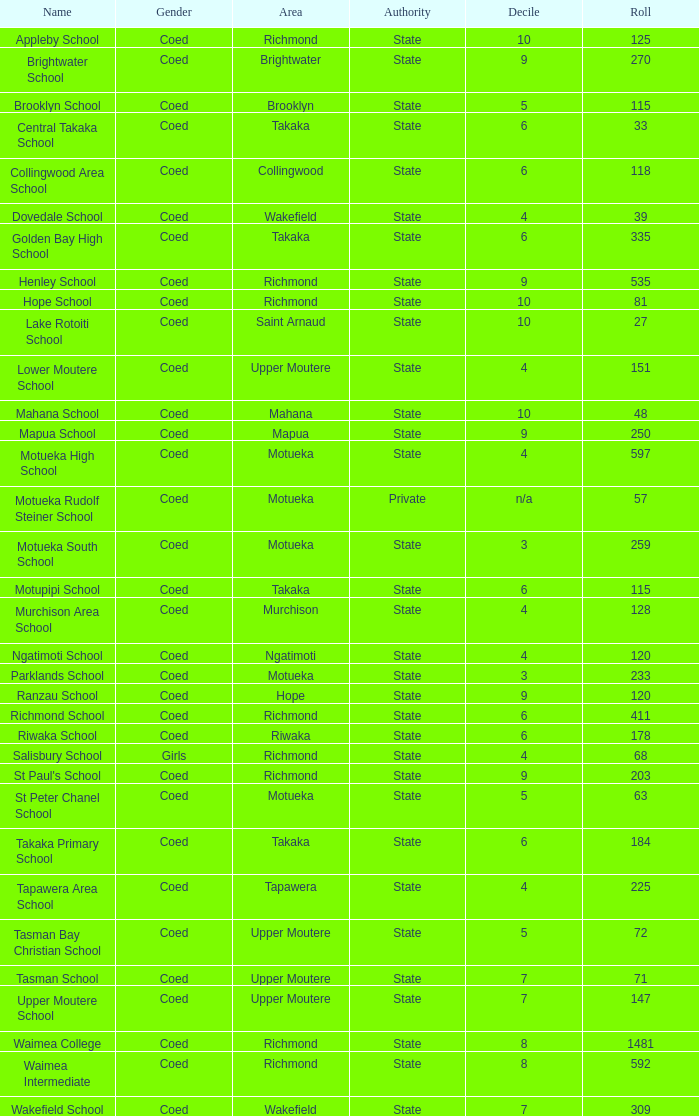In which zone is central takaka school situated? Takaka. 